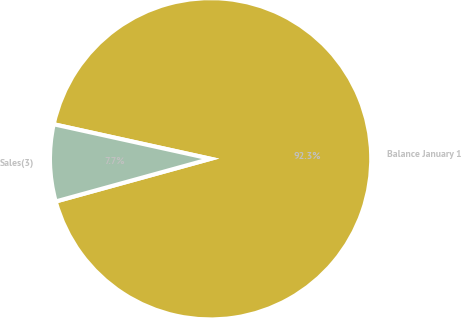<chart> <loc_0><loc_0><loc_500><loc_500><pie_chart><fcel>Balance January 1<fcel>Sales(3)<nl><fcel>92.27%<fcel>7.73%<nl></chart> 